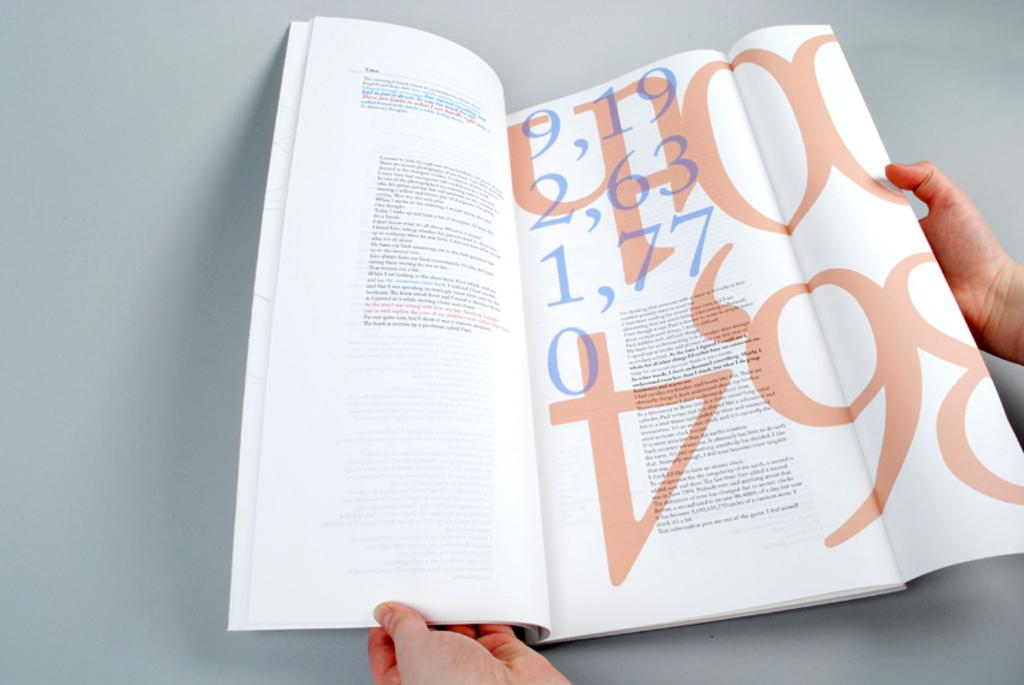<image>
Present a compact description of the photo's key features. A magazine being held open to show the number 9,19 2,63 1,77 and 0 